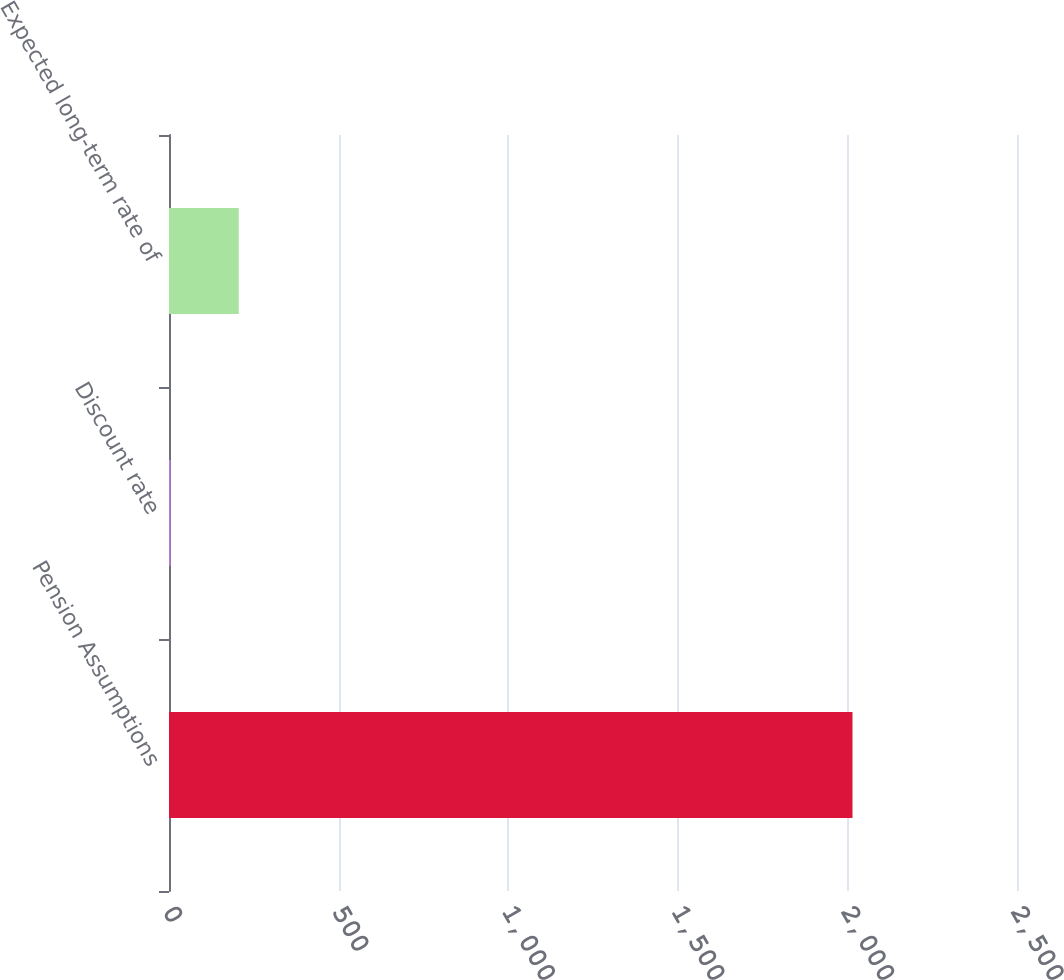<chart> <loc_0><loc_0><loc_500><loc_500><bar_chart><fcel>Pension Assumptions<fcel>Discount rate<fcel>Expected long-term rate of<nl><fcel>2015<fcel>4.66<fcel>205.69<nl></chart> 